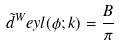Convert formula to latex. <formula><loc_0><loc_0><loc_500><loc_500>\tilde { d } ^ { W } e y l ( \phi ; k ) = \frac { B } { \pi }</formula> 